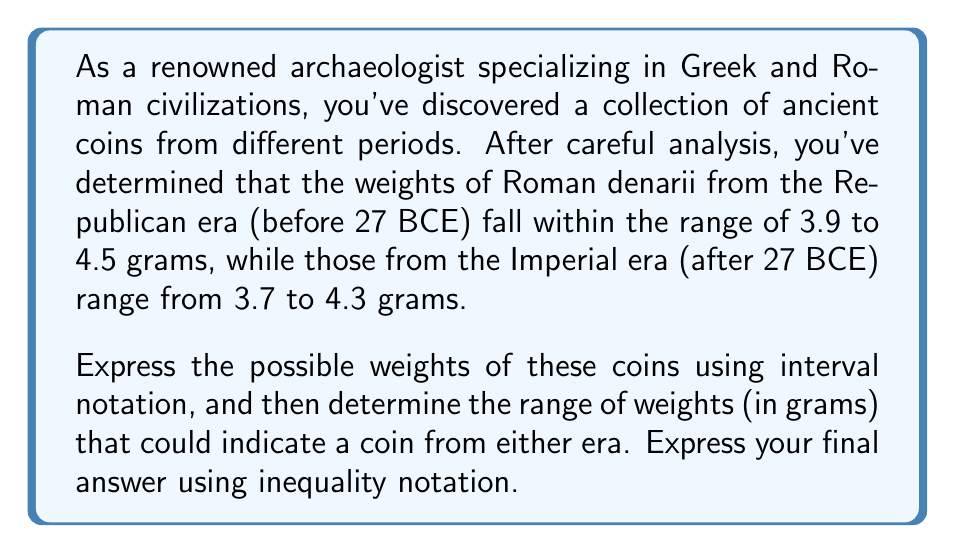Provide a solution to this math problem. Let's approach this step-by-step:

1) First, let's express the weight ranges in interval notation:

   Republican era: $[3.9, 4.5]$
   Imperial era: $[3.7, 4.3]$

2) To find the range of weights that could indicate a coin from either era, we need to find the intersection of these two intervals.

3) The intersection will start at the larger of the two lower bounds and end at the smaller of the two upper bounds:

   Larger lower bound: $\max(3.7, 3.9) = 3.9$
   Smaller upper bound: $\min(4.3, 4.5) = 4.3$

4) Therefore, the intersection is $[3.9, 4.3]$

5) To express this in inequality notation, we write:

   $3.9 \leq x \leq 4.3$

   where $x$ represents the weight of the coin in grams.

This inequality represents the range of weights where a coin could be from either the Republican or Imperial era.
Answer: $3.9 \leq x \leq 4.3$, where $x$ is the weight of the coin in grams. 